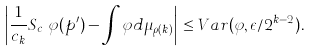<formula> <loc_0><loc_0><loc_500><loc_500>\left | \frac { 1 } { c _ { k } } S _ { c _ { k } } \varphi ( p ^ { \prime } ) - \int \varphi d \mu _ { \rho ( k ) } \right | \leq V a r ( \varphi , \epsilon / 2 ^ { k - 2 } ) .</formula> 